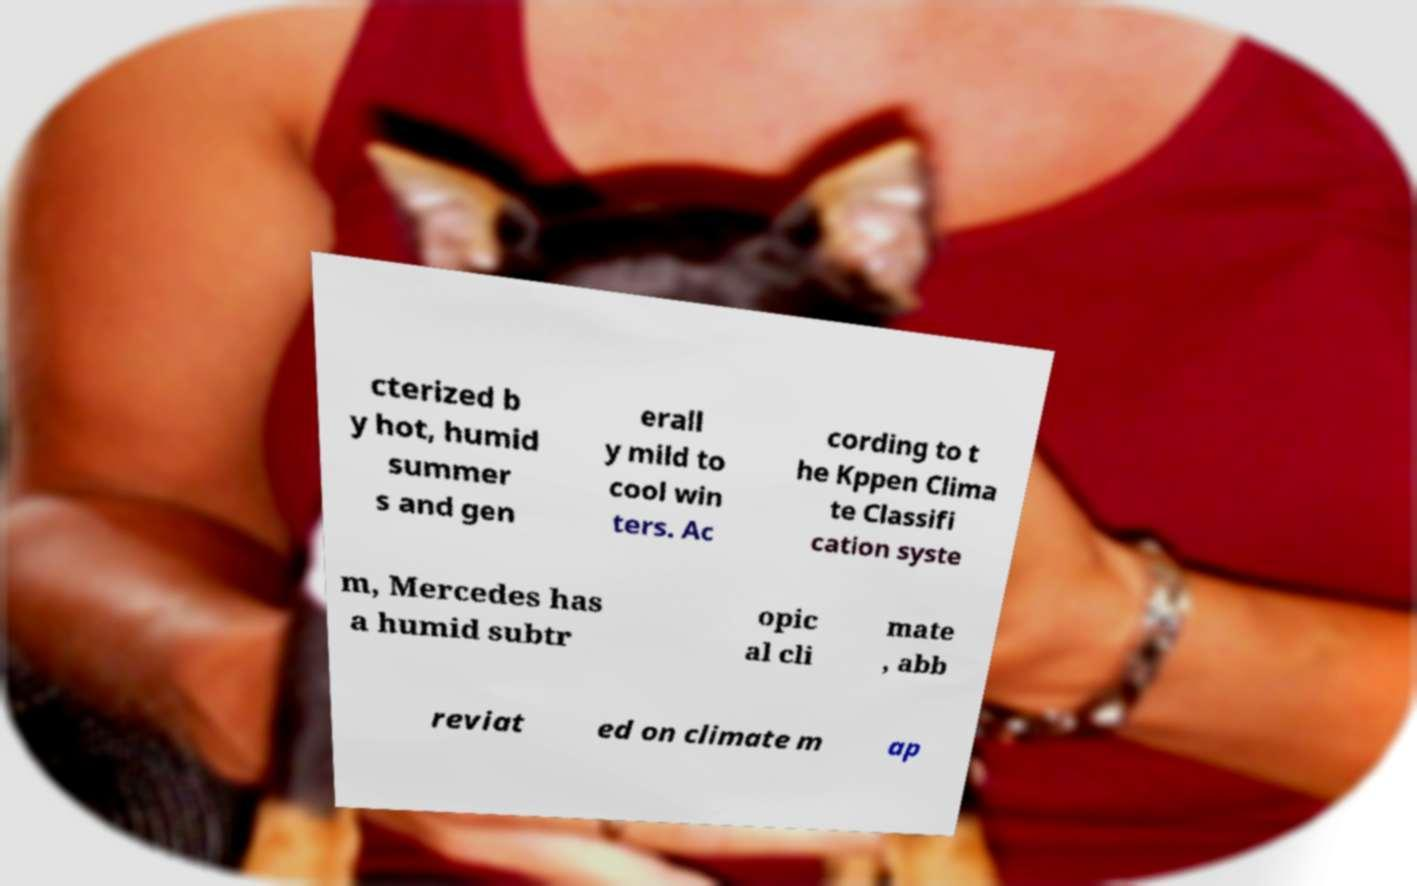Please read and relay the text visible in this image. What does it say? cterized b y hot, humid summer s and gen erall y mild to cool win ters. Ac cording to t he Kppen Clima te Classifi cation syste m, Mercedes has a humid subtr opic al cli mate , abb reviat ed on climate m ap 